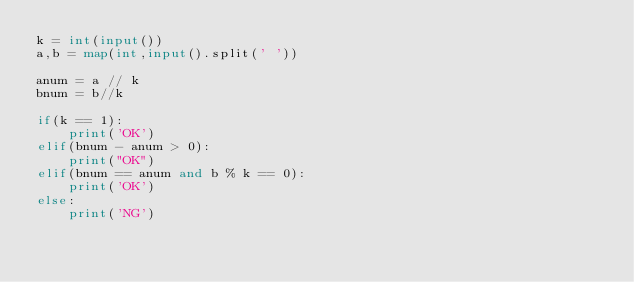Convert code to text. <code><loc_0><loc_0><loc_500><loc_500><_Python_>k = int(input()) 
a,b = map(int,input().split(' '))

anum = a // k
bnum = b//k

if(k == 1):
    print('OK')
elif(bnum - anum > 0):
    print("OK")
elif(bnum == anum and b % k == 0):
    print('OK')
else:
    print('NG')</code> 